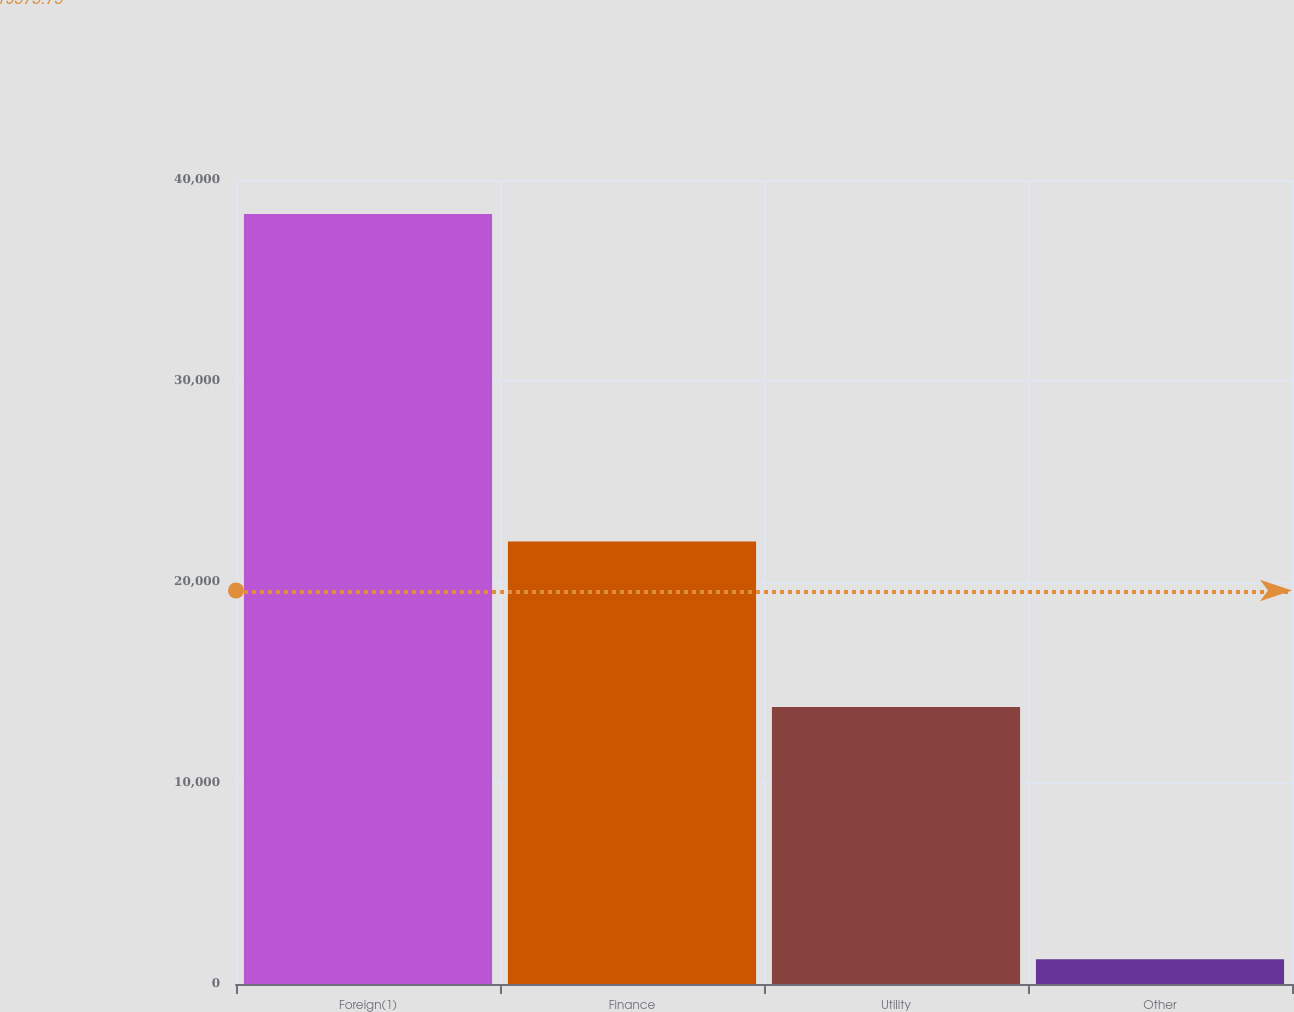<chart> <loc_0><loc_0><loc_500><loc_500><bar_chart><fcel>Foreign(1)<fcel>Finance<fcel>Utility<fcel>Other<nl><fcel>38305<fcel>22013<fcel>13780<fcel>1234<nl></chart> 